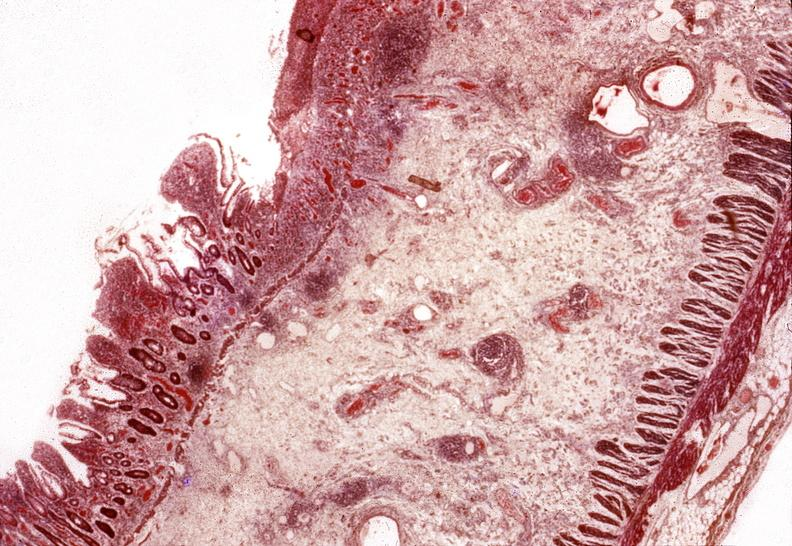does chest and abdomen slide show small intestine, regional enteritis?
Answer the question using a single word or phrase. No 